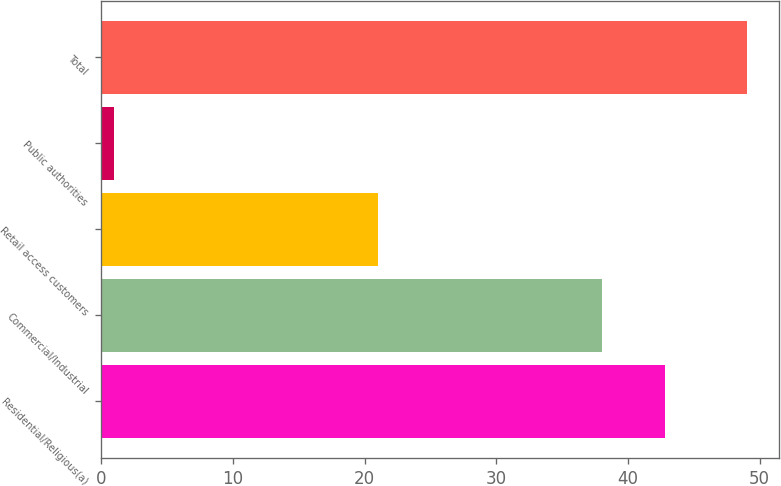<chart> <loc_0><loc_0><loc_500><loc_500><bar_chart><fcel>Residential/Religious(a)<fcel>Commercial/Industrial<fcel>Retail access customers<fcel>Public authorities<fcel>Total<nl><fcel>42.8<fcel>38<fcel>21<fcel>1<fcel>49<nl></chart> 